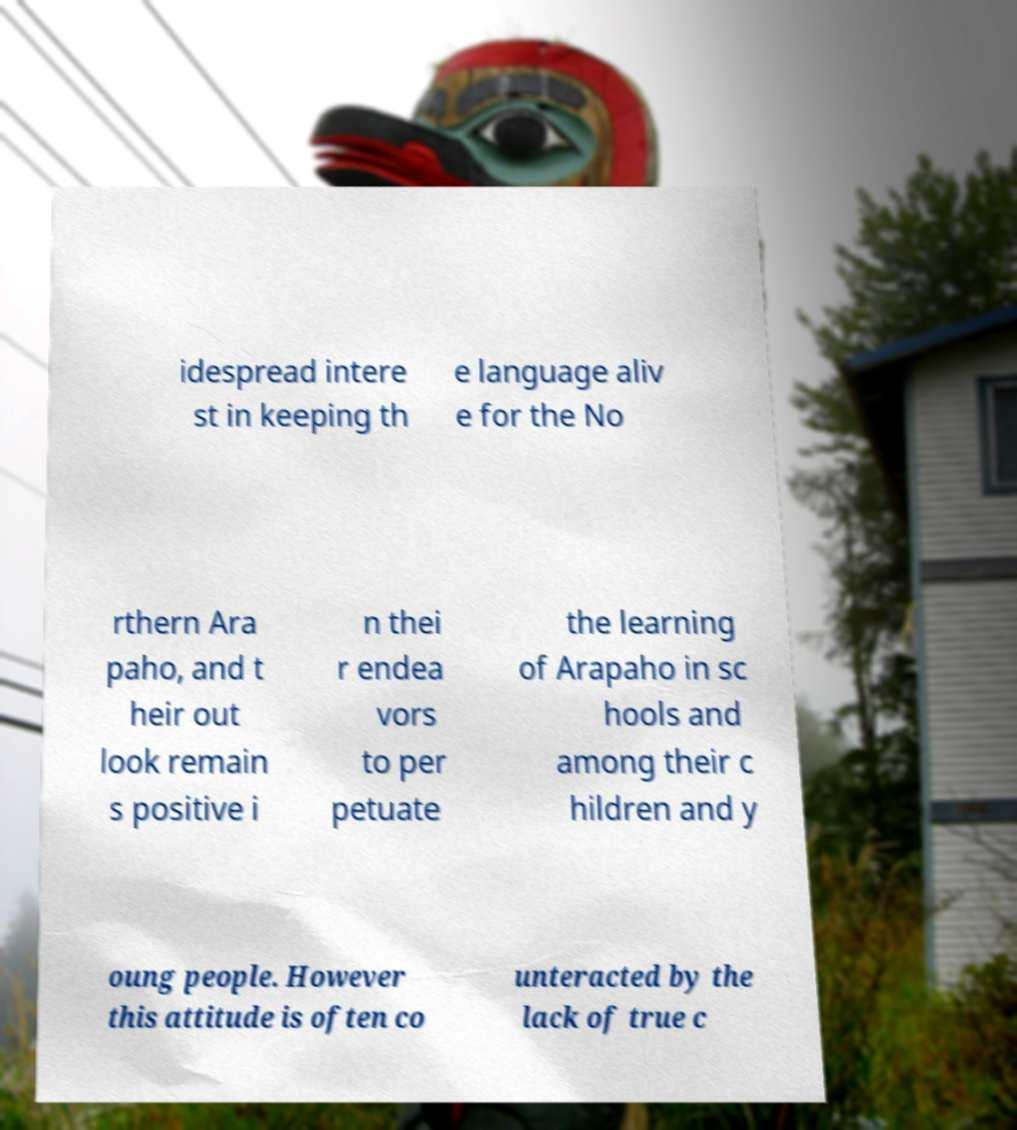I need the written content from this picture converted into text. Can you do that? idespread intere st in keeping th e language aliv e for the No rthern Ara paho, and t heir out look remain s positive i n thei r endea vors to per petuate the learning of Arapaho in sc hools and among their c hildren and y oung people. However this attitude is often co unteracted by the lack of true c 